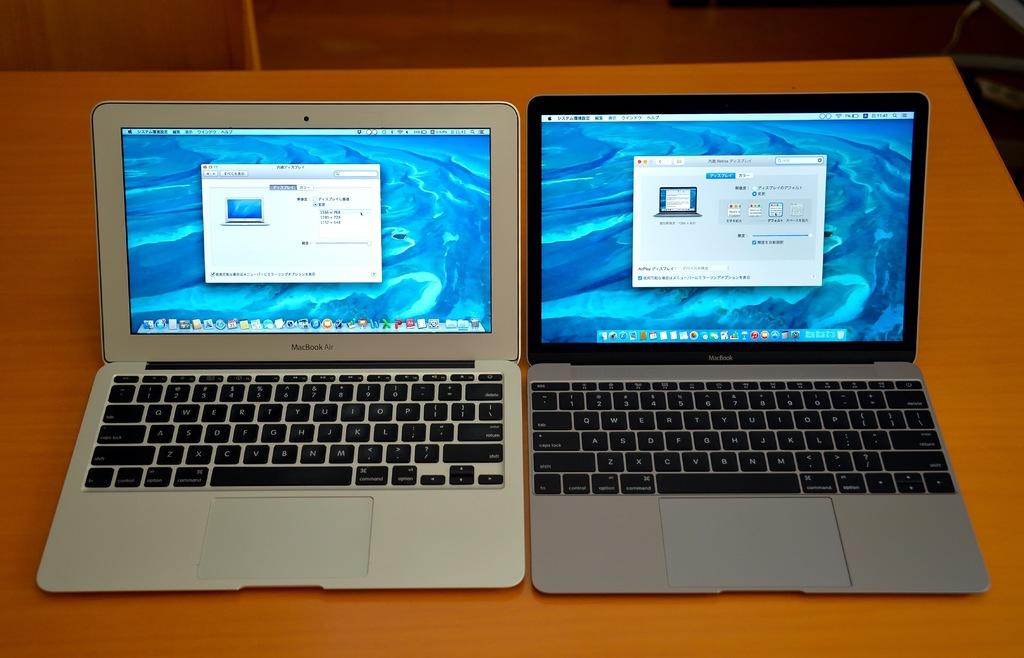Provide a one-sentence caption for the provided image. Two laptop computers sitting side by side with the one of the left having a screen display setting of 1366 x 768. 